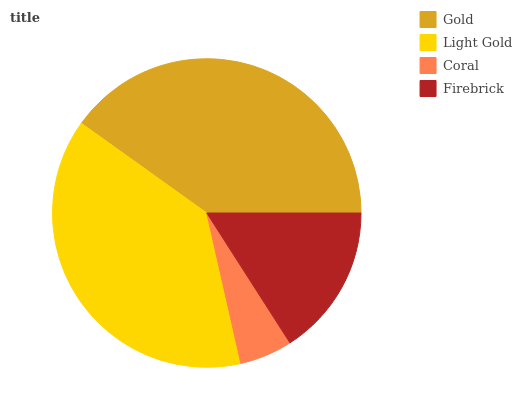Is Coral the minimum?
Answer yes or no. Yes. Is Gold the maximum?
Answer yes or no. Yes. Is Light Gold the minimum?
Answer yes or no. No. Is Light Gold the maximum?
Answer yes or no. No. Is Gold greater than Light Gold?
Answer yes or no. Yes. Is Light Gold less than Gold?
Answer yes or no. Yes. Is Light Gold greater than Gold?
Answer yes or no. No. Is Gold less than Light Gold?
Answer yes or no. No. Is Light Gold the high median?
Answer yes or no. Yes. Is Firebrick the low median?
Answer yes or no. Yes. Is Gold the high median?
Answer yes or no. No. Is Coral the low median?
Answer yes or no. No. 